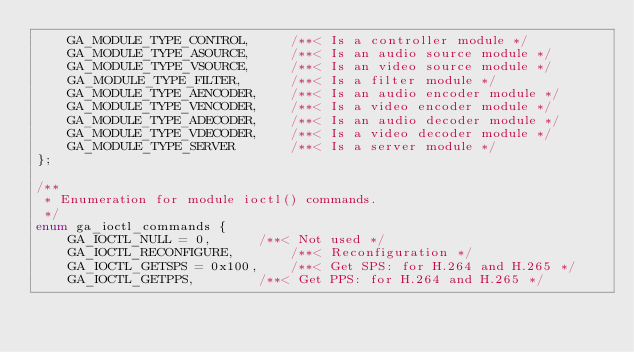<code> <loc_0><loc_0><loc_500><loc_500><_C_>	GA_MODULE_TYPE_CONTROL,		/**< Is a controller module */
	GA_MODULE_TYPE_ASOURCE,		/**< Is an audio source module */
	GA_MODULE_TYPE_VSOURCE,		/**< Is an video source module */
	GA_MODULE_TYPE_FILTER,		/**< Is a filter module */
	GA_MODULE_TYPE_AENCODER,	/**< Is an audio encoder module */
	GA_MODULE_TYPE_VENCODER,	/**< Is a video encoder module */
	GA_MODULE_TYPE_ADECODER,	/**< Is an audio decoder module */
	GA_MODULE_TYPE_VDECODER,	/**< Is a video decoder module */
	GA_MODULE_TYPE_SERVER		/**< Is a server module */
};

/**
 * Enumeration for module ioctl() commands.
 */
enum ga_ioctl_commands {
	GA_IOCTL_NULL = 0,		/**< Not used */
	GA_IOCTL_RECONFIGURE,		/**< Reconfiguration */
	GA_IOCTL_GETSPS = 0x100,	/**< Get SPS: for H.264 and H.265 */
	GA_IOCTL_GETPPS,		/**< Get PPS: for H.264 and H.265 */</code> 